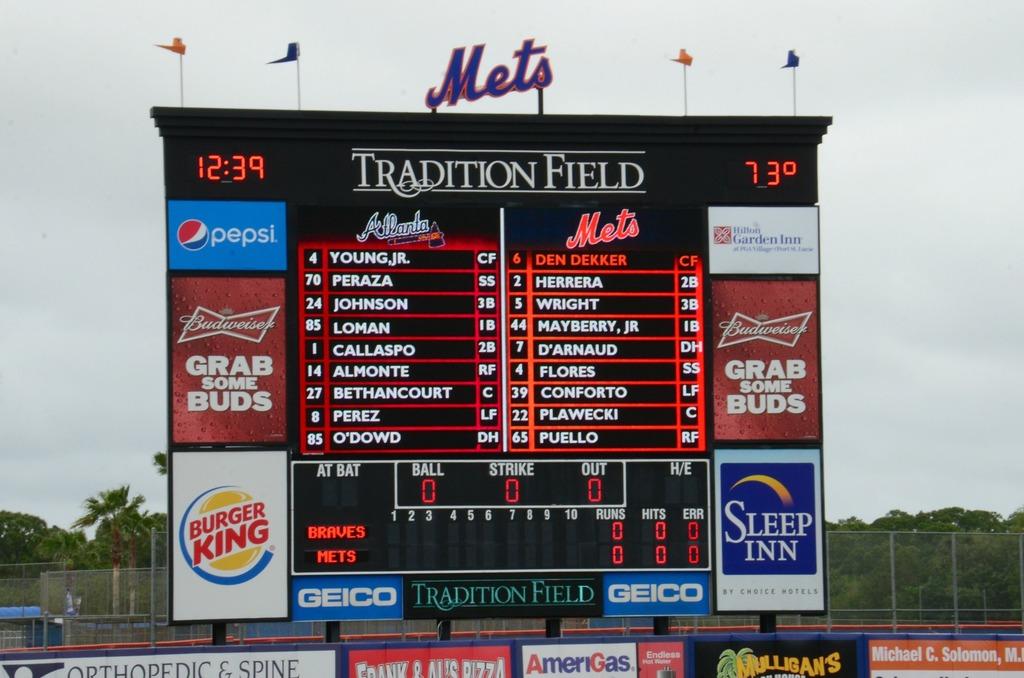What fast food restaurant is advertised?
Keep it short and to the point. Burger king. 